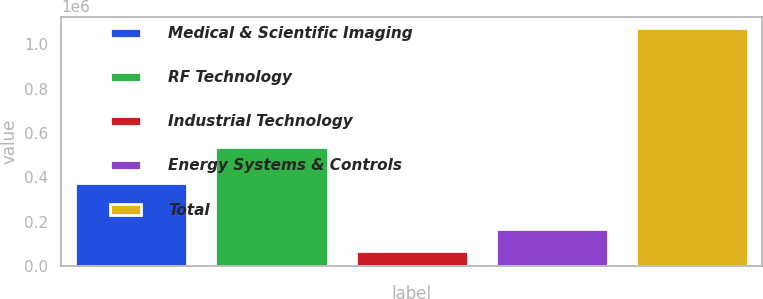Convert chart to OTSL. <chart><loc_0><loc_0><loc_500><loc_500><bar_chart><fcel>Medical & Scientific Imaging<fcel>RF Technology<fcel>Industrial Technology<fcel>Energy Systems & Controls<fcel>Total<nl><fcel>373213<fcel>538877<fcel>68002<fcel>168248<fcel>1.07046e+06<nl></chart> 